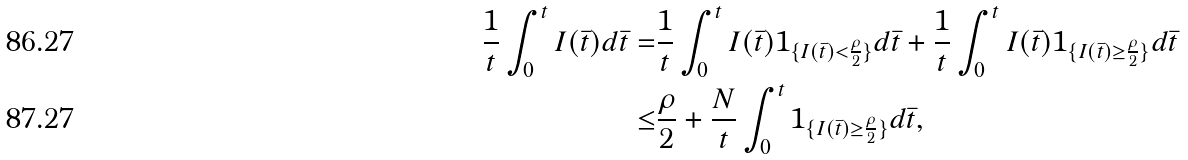<formula> <loc_0><loc_0><loc_500><loc_500>\frac { 1 } t \int ^ { t } _ { 0 } I ( \bar { t } ) d \bar { t } = & \frac { 1 } t \int ^ { t } _ { 0 } I ( \bar { t } ) { 1 } _ { \{ I ( \bar { t } ) < \frac { \rho } 2 \} } d \bar { t } + \frac { 1 } t \int ^ { t } _ { 0 } I ( \bar { t } ) { 1 } _ { \{ I ( \bar { t } ) \geq \frac { \rho } 2 \} } d \bar { t } \\ \leq & \frac { \rho } 2 + \frac { N } { t } \int ^ { t } _ { 0 } { 1 } _ { \{ I ( \bar { t } ) \geq \frac { \rho } 2 \} } d \bar { t } ,</formula> 